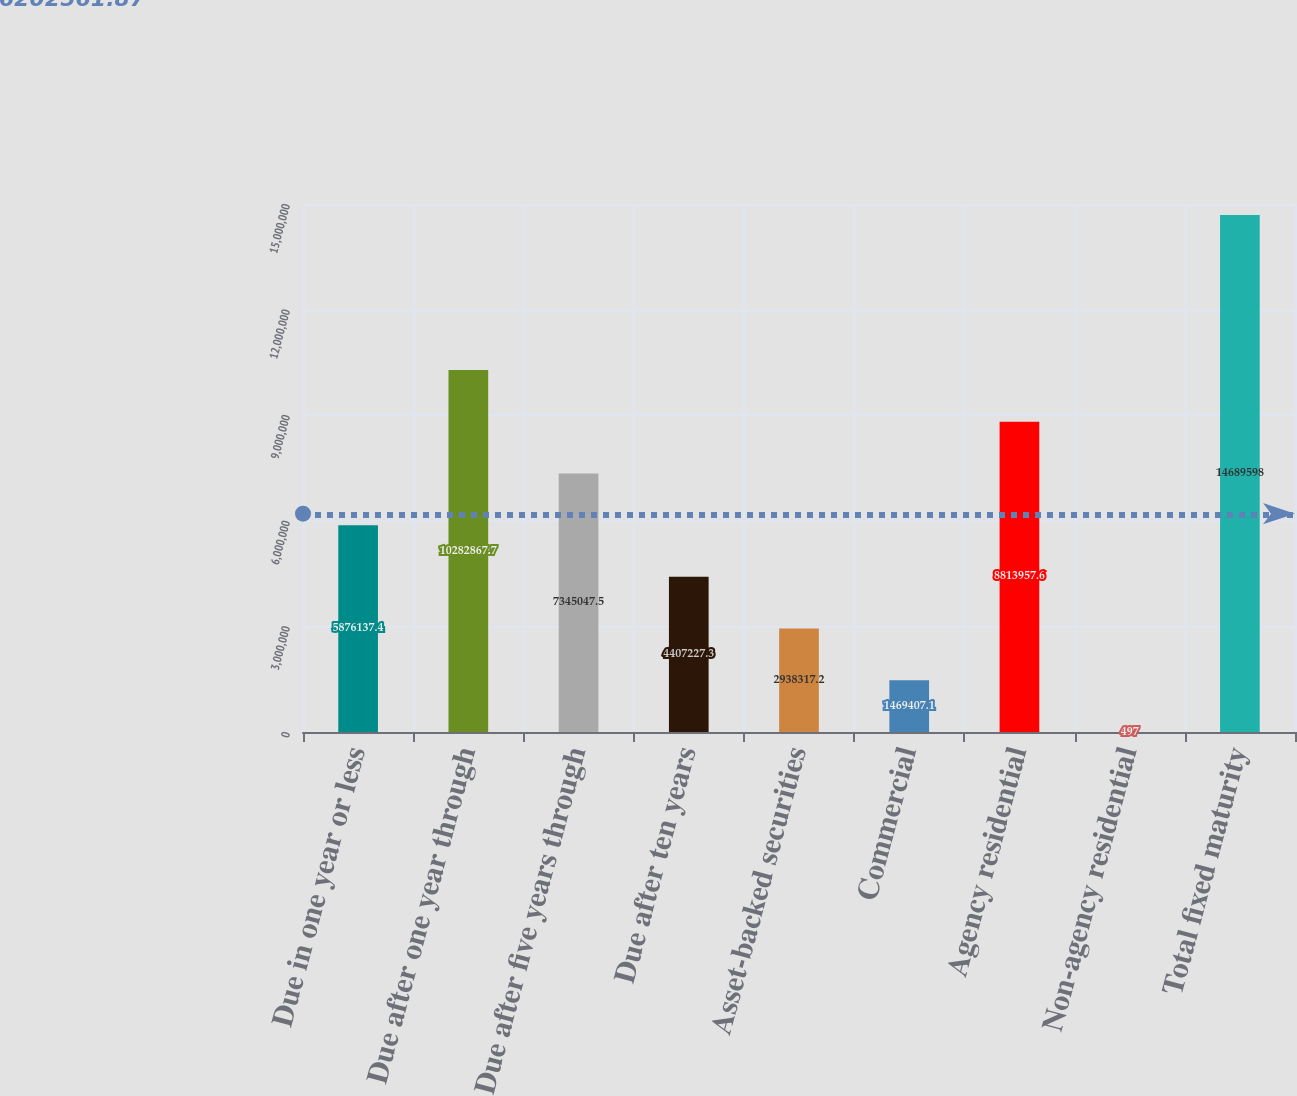<chart> <loc_0><loc_0><loc_500><loc_500><bar_chart><fcel>Due in one year or less<fcel>Due after one year through<fcel>Due after five years through<fcel>Due after ten years<fcel>Asset-backed securities<fcel>Commercial<fcel>Agency residential<fcel>Non-agency residential<fcel>Total fixed maturity<nl><fcel>5.87614e+06<fcel>1.02829e+07<fcel>7.34505e+06<fcel>4.40723e+06<fcel>2.93832e+06<fcel>1.46941e+06<fcel>8.81396e+06<fcel>497<fcel>1.46896e+07<nl></chart> 